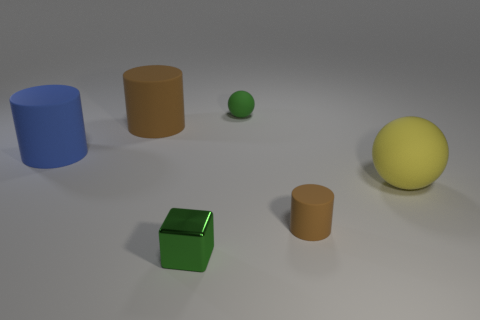What number of things are large blue objects left of the green rubber ball or large things that are on the left side of the big brown rubber thing?
Give a very brief answer. 1. There is a green sphere that is the same material as the large blue thing; what is its size?
Keep it short and to the point. Small. What number of rubber objects are tiny green objects or large cylinders?
Provide a succinct answer. 3. The cube is what size?
Your answer should be very brief. Small. Is the size of the cube the same as the green ball?
Ensure brevity in your answer.  Yes. There is a large cylinder behind the big blue rubber thing; what material is it?
Make the answer very short. Rubber. What is the material of the big blue object that is the same shape as the large brown rubber object?
Provide a succinct answer. Rubber. There is a tiny green object that is in front of the yellow matte sphere; is there a big brown object that is to the right of it?
Offer a very short reply. No. Do the tiny green metallic object and the small green rubber object have the same shape?
Offer a terse response. No. The small brown object that is the same material as the blue object is what shape?
Provide a succinct answer. Cylinder. 